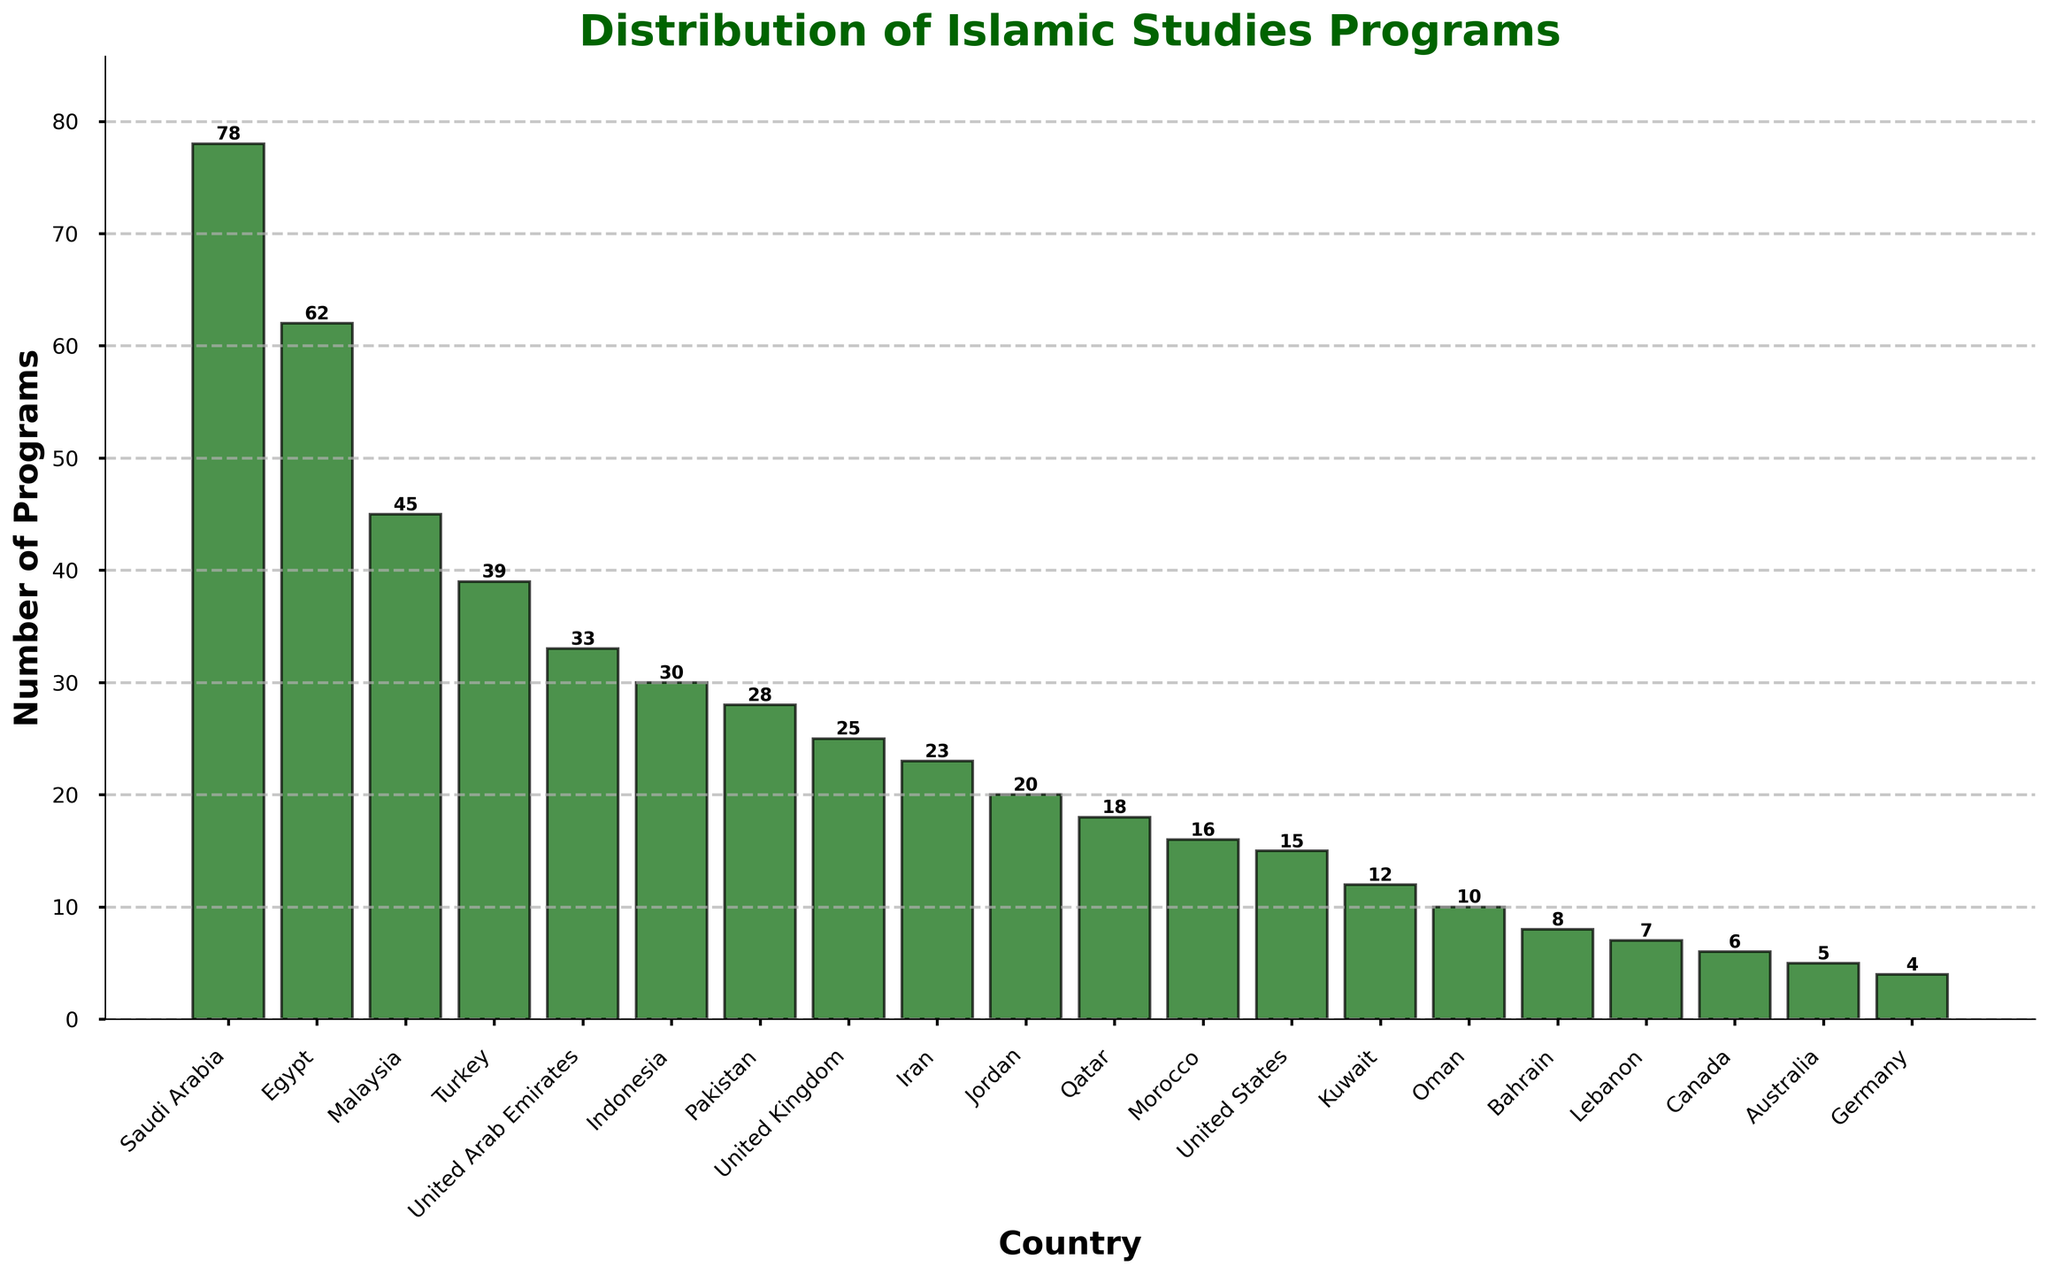Which country has the highest number of Islamic Studies programs? The figure shows that the tallest bar represents Saudi Arabia, indicating the highest number of programs.
Answer: Saudi Arabia Which three countries have the lowest number of Islamic Studies programs, and what are their counts? By visually identifying the shortest bars, the countries are Lebanon (7), Canada (6), and Australia (5).
Answer: Lebanon (7), Canada (6), Australia (5) How many more Islamic Studies programs does Saudi Arabia have compared to Egypt? Saudi Arabia has 78 programs, and Egypt has 62 programs. The difference is 78 - 62 = 16.
Answer: 16 What is the average number of Islamic Studies programs for the countries with more than 20 programs? Adding the number of programs for countries with more than 20 programs (78 + 62 + 45 + 39 + 33 + 30 + 28 + 25 + 23) gives 363. There are 9 such countries, so the average is 363/9 = 40.33.
Answer: 40.33 Which country has the lowest number of Islamic Studies programs among those with exactly or fewer than 10 programs? From the figure, Australia has 5 programs, the lowest among countries with 10 or fewer programs.
Answer: Australia How many Islamic Studies programs are there in total for Egypt, Malaysia, and Turkey? Summing the programs for these countries: 62 (Egypt) + 45 (Malaysia) + 39 (Turkey) = 146.
Answer: 146 What is the total number of Islamic Studies programs offered by all the countries in the figure? Summing the programs for all countries: 78 + 62 + 45 + 39 + 33 + 30 + 28 + 25 + 23 + 20 + 18 + 16 + 15 + 12 + 10 + 8 + 7 + 6 + 5 + 4 = 486.
Answer: 486 Which countries have a similar number of Islamic Studies programs to Pakistan, and what are their counts? Pakistan has 28 programs. The figure shows the closest counts are Indonesia (30) and the United Kingdom (25).
Answer: Indonesia (30), United Kingdom (25) What pattern can be observed in the distribution of Islamic Studies programs compared to Western countries (United Kingdom, United States, Canada, Australia, Germany)? Observing the figure, Western countries have significantly fewer programs compared to predominantly Muslim countries. The total for these Western countries is 25 (UK) + 15 (US) + 6 (Canada) + 5 (Australia) + 4 (Germany) = 55.
Answer: Predominantly Muslim countries have more programs compared to Western countries 